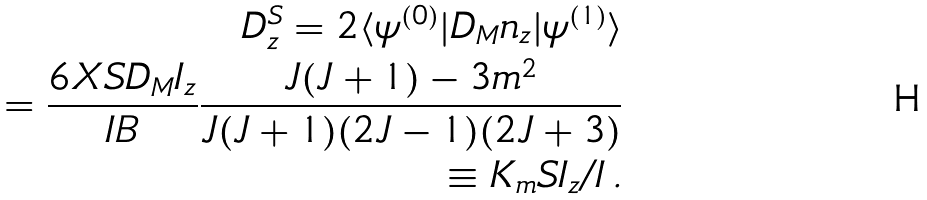<formula> <loc_0><loc_0><loc_500><loc_500>D _ { z } ^ { S } = 2 \langle \psi ^ { ( 0 ) } | D _ { M } n _ { z } | \psi ^ { ( 1 ) } \rangle \\ = \frac { 6 X S D _ { M } I _ { z } } { I B } \frac { J ( J + 1 ) - 3 m ^ { 2 } } { J ( J + 1 ) ( 2 J - 1 ) ( 2 J + 3 ) } \\ \equiv K _ { m } S I _ { z } / I \, .</formula> 